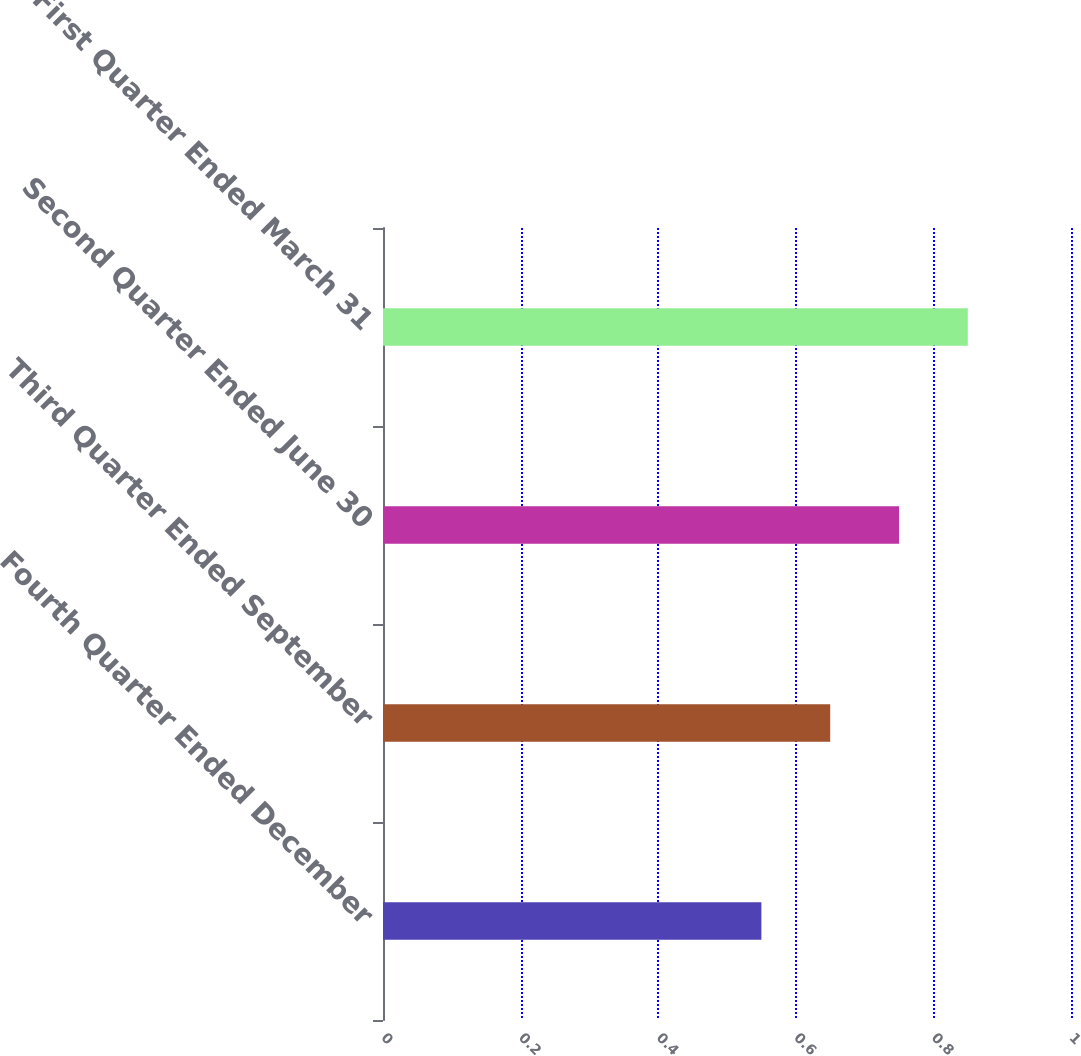Convert chart to OTSL. <chart><loc_0><loc_0><loc_500><loc_500><bar_chart><fcel>Fourth Quarter Ended December<fcel>Third Quarter Ended September<fcel>Second Quarter Ended June 30<fcel>First Quarter Ended March 31<nl><fcel>0.55<fcel>0.65<fcel>0.75<fcel>0.85<nl></chart> 